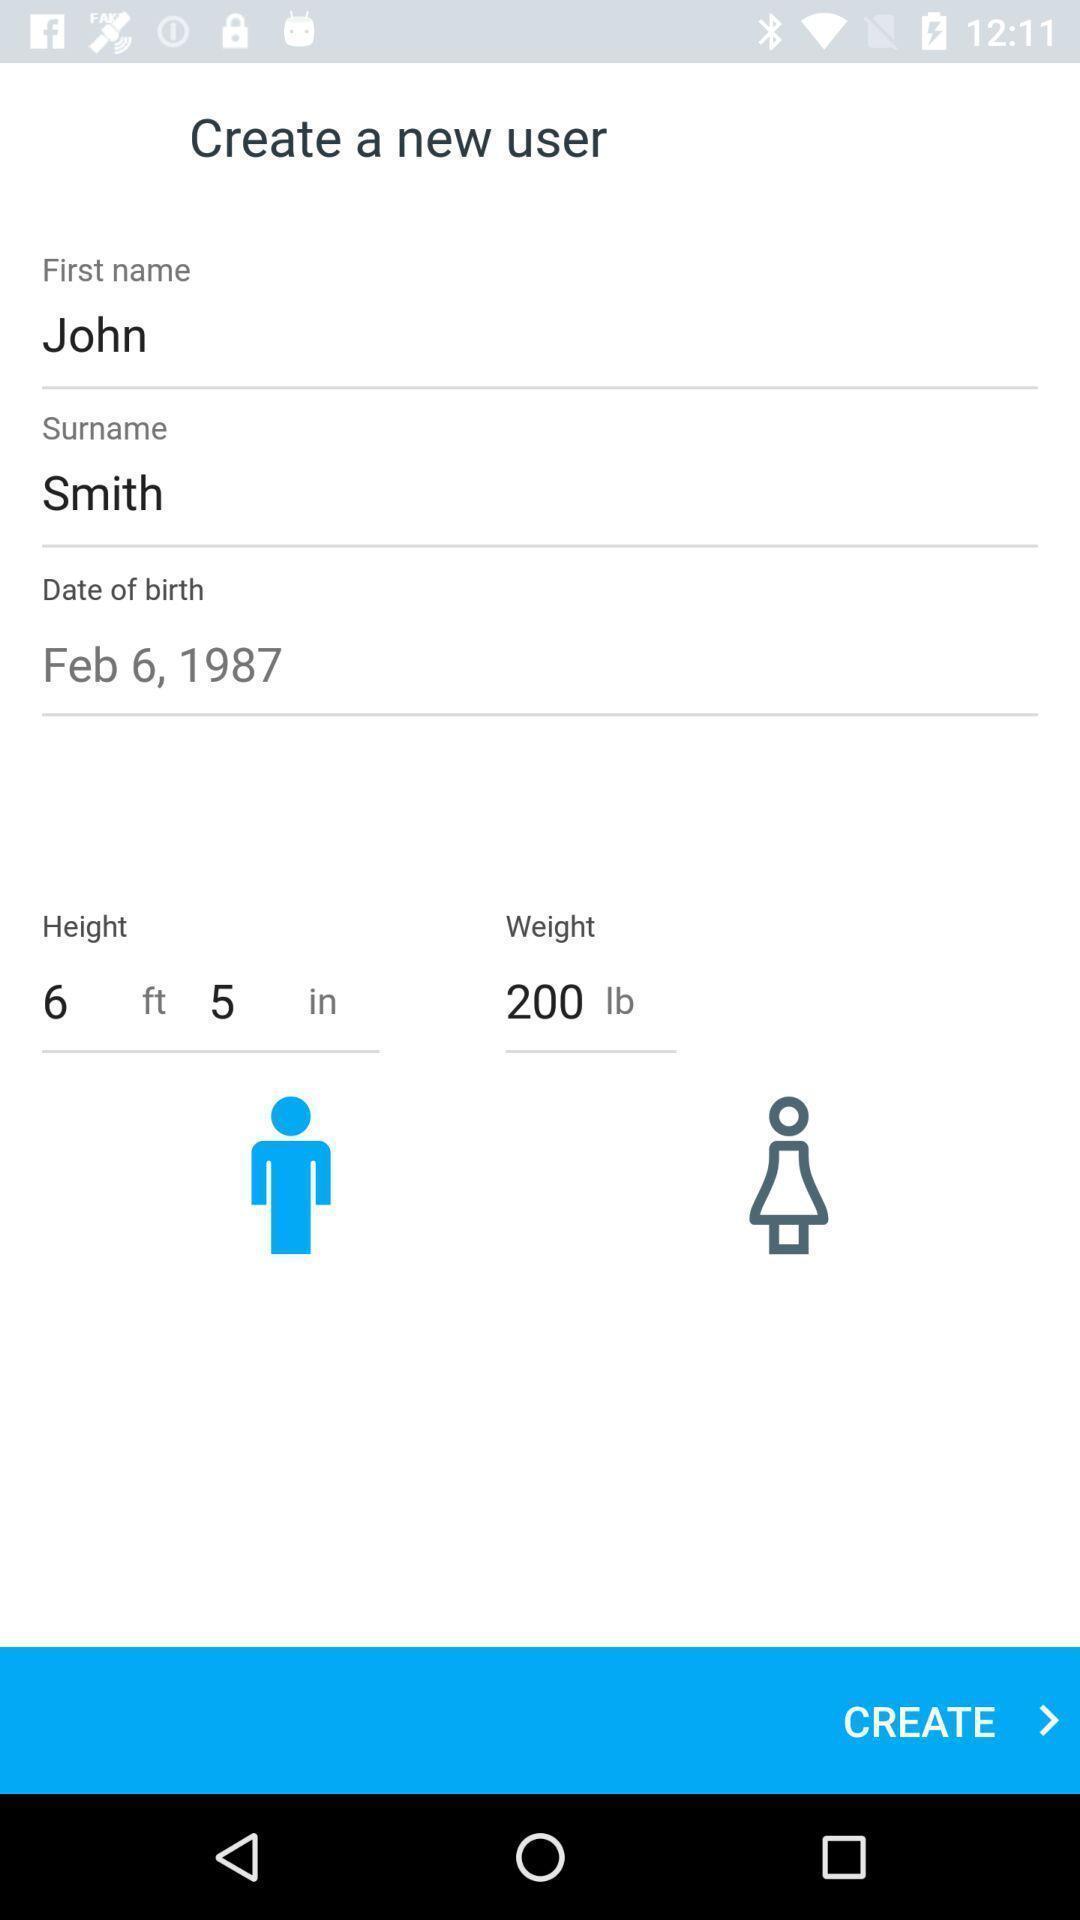Give me a summary of this screen capture. User profile creating page in a health app. 